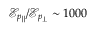Convert formula to latex. <formula><loc_0><loc_0><loc_500><loc_500>\mathcal { E } _ { p _ { \| } } / \mathcal { E } _ { p _ { \perp } } \sim 1 0 0 0</formula> 